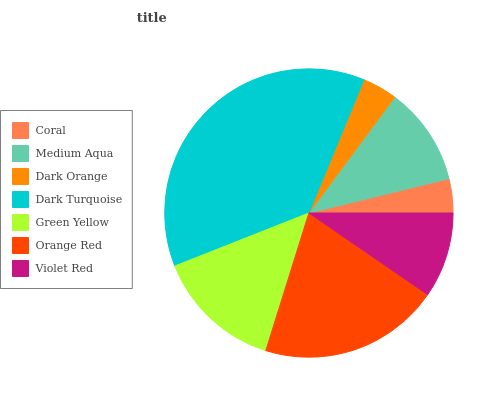Is Coral the minimum?
Answer yes or no. Yes. Is Dark Turquoise the maximum?
Answer yes or no. Yes. Is Medium Aqua the minimum?
Answer yes or no. No. Is Medium Aqua the maximum?
Answer yes or no. No. Is Medium Aqua greater than Coral?
Answer yes or no. Yes. Is Coral less than Medium Aqua?
Answer yes or no. Yes. Is Coral greater than Medium Aqua?
Answer yes or no. No. Is Medium Aqua less than Coral?
Answer yes or no. No. Is Medium Aqua the high median?
Answer yes or no. Yes. Is Medium Aqua the low median?
Answer yes or no. Yes. Is Dark Orange the high median?
Answer yes or no. No. Is Dark Turquoise the low median?
Answer yes or no. No. 